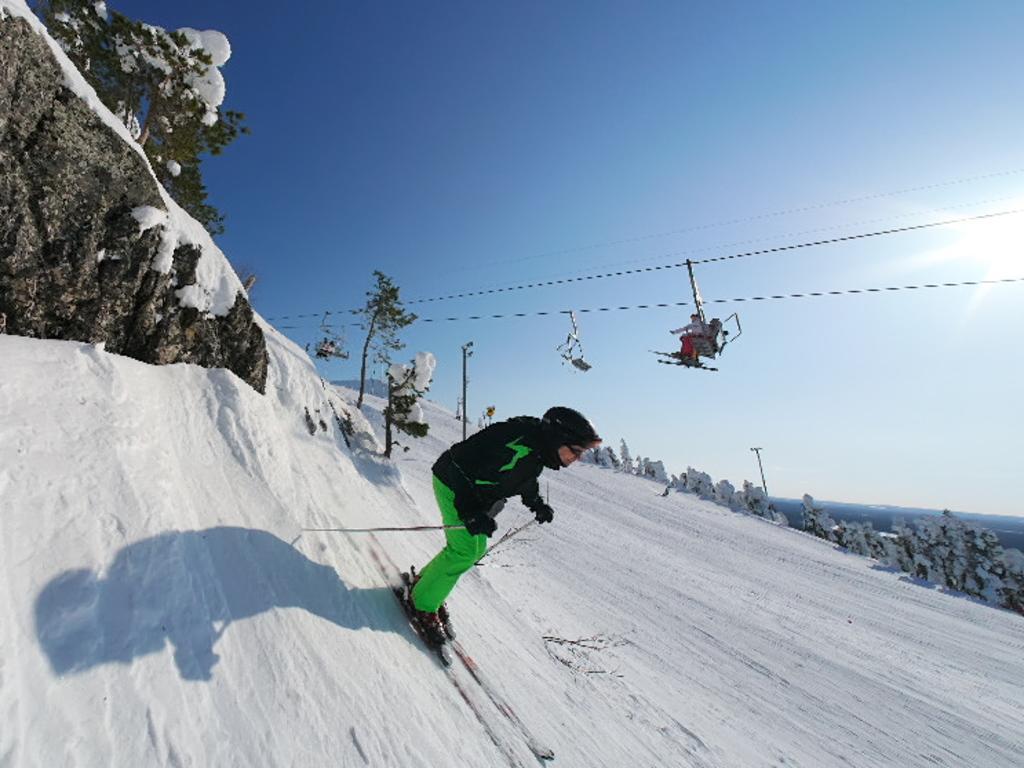Can you describe this image briefly? In this image there is one person who is skating, at the bottom there is snow and in the center there is a cable car and some wires. On the left side there are mountains and on the right side there are some trees and mountains, on the top of the image there is sky. 